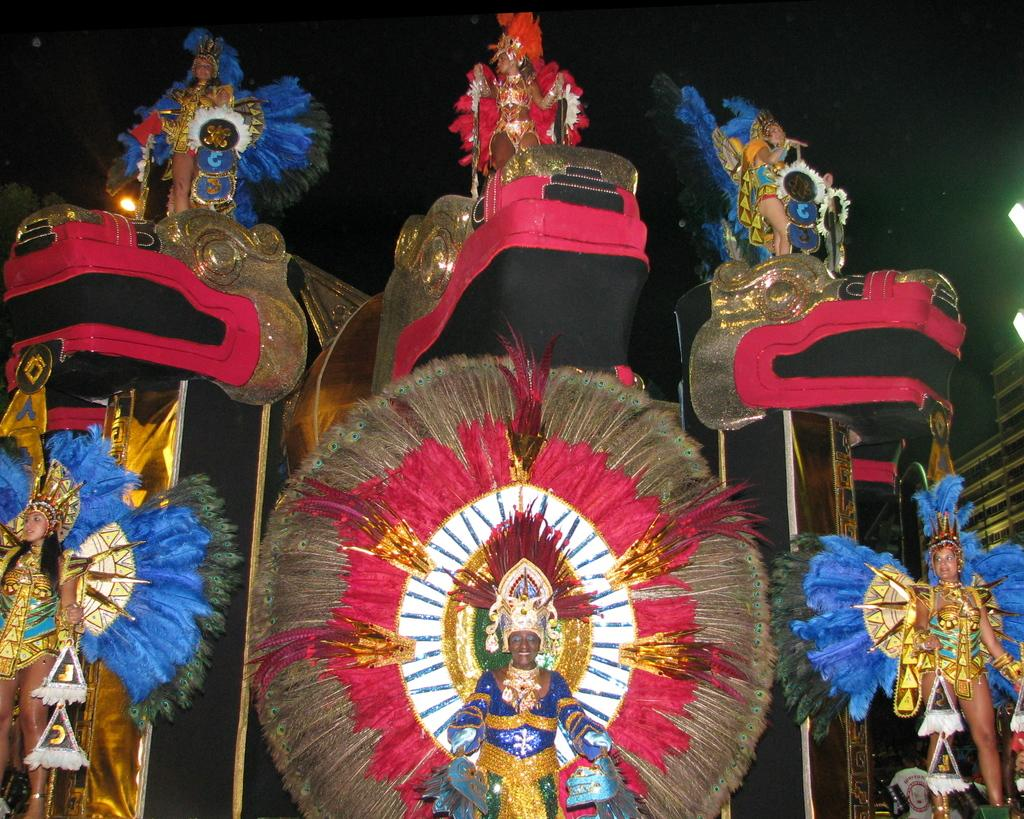What is the main subject of the image? The main subject of the image is a group of people. What are the people wearing in the image? The people are wearing costumes in the image. Can you describe the lighting in the image? There are lights on the right side of the image. How many tomatoes are being combed on the island in the image? There is no island, tomatoes, or comb present in the image. 